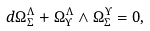<formula> <loc_0><loc_0><loc_500><loc_500>d \Omega _ { \Sigma } ^ { \Lambda } + \Omega _ { \Upsilon } ^ { \Lambda } \wedge \Omega _ { \Sigma } ^ { \Upsilon } = 0 ,</formula> 